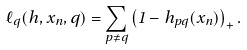Convert formula to latex. <formula><loc_0><loc_0><loc_500><loc_500>\ell _ { q } ( h , x _ { n } , q ) = \sum _ { p \neq q } \left ( 1 - h _ { p q } ( x _ { n } ) \right ) _ { + } .</formula> 